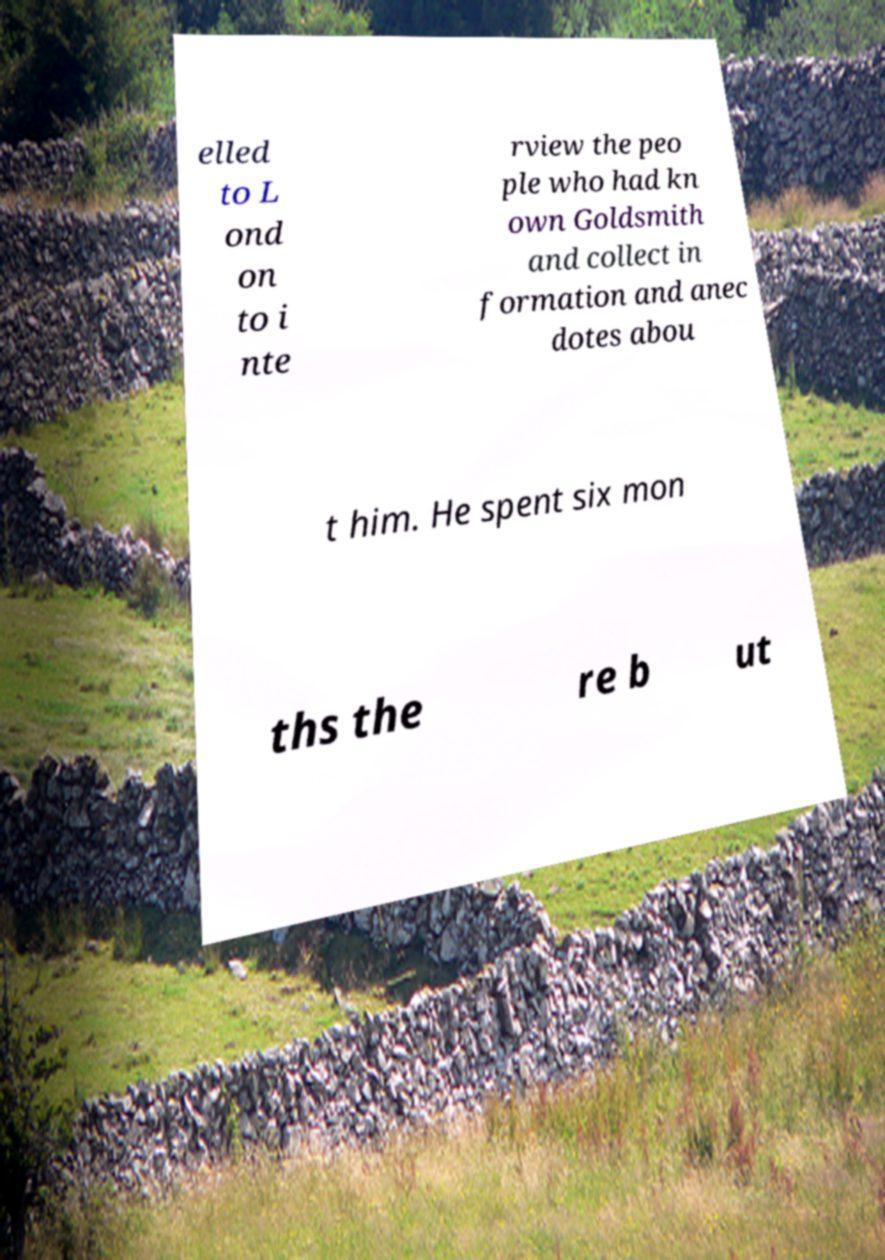Please identify and transcribe the text found in this image. elled to L ond on to i nte rview the peo ple who had kn own Goldsmith and collect in formation and anec dotes abou t him. He spent six mon ths the re b ut 